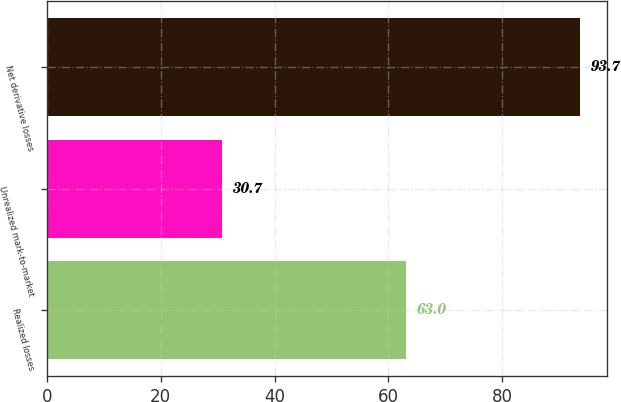Convert chart to OTSL. <chart><loc_0><loc_0><loc_500><loc_500><bar_chart><fcel>Realized losses<fcel>Unrealized mark-to-market<fcel>Net derivative losses<nl><fcel>63<fcel>30.7<fcel>93.7<nl></chart> 